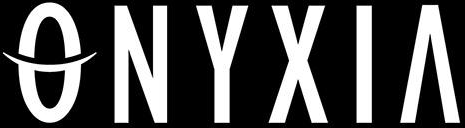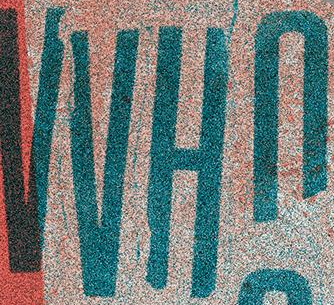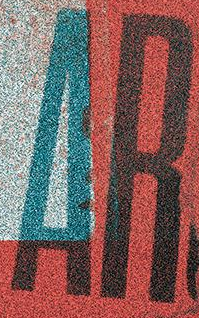Transcribe the words shown in these images in order, separated by a semicolon. ONYXIA; VVHn; AR 